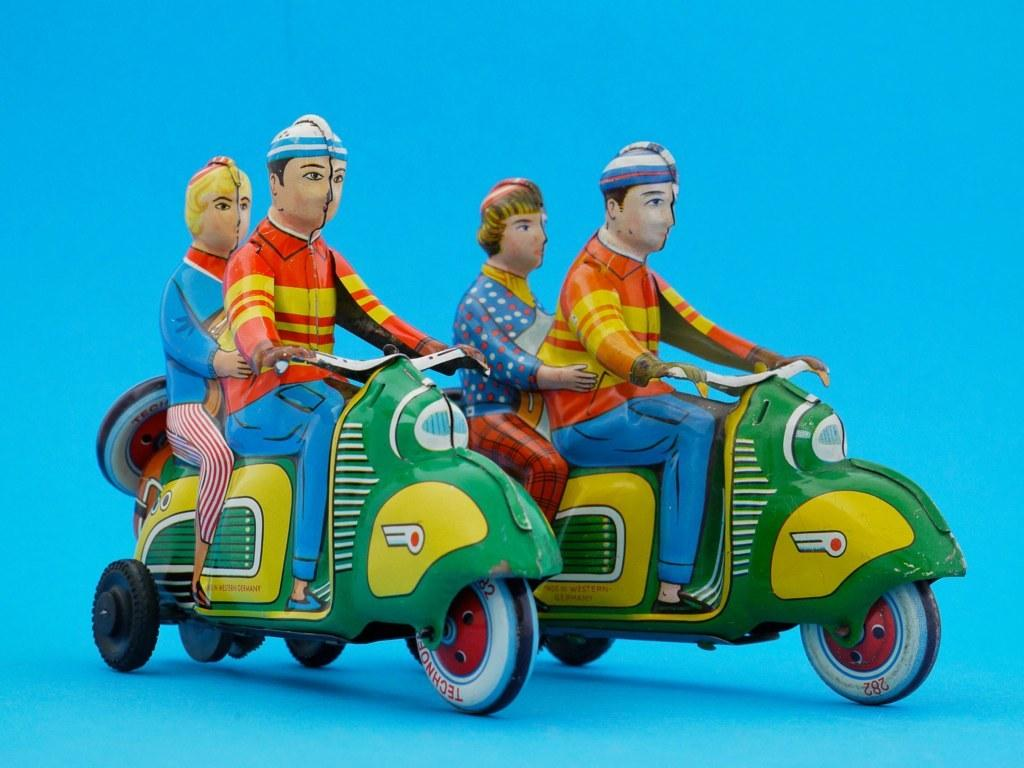How many people are in the image? There are four people in the image. What are the two men in the image doing? The two men are riding scooters. Are there any other people on the scooters? Yes, there are two people sitting at the back of the scooters. What type of brush can be seen in the image? There is no brush present in the image. Is there a cellar visible in the image? There is no cellar present in the image. 